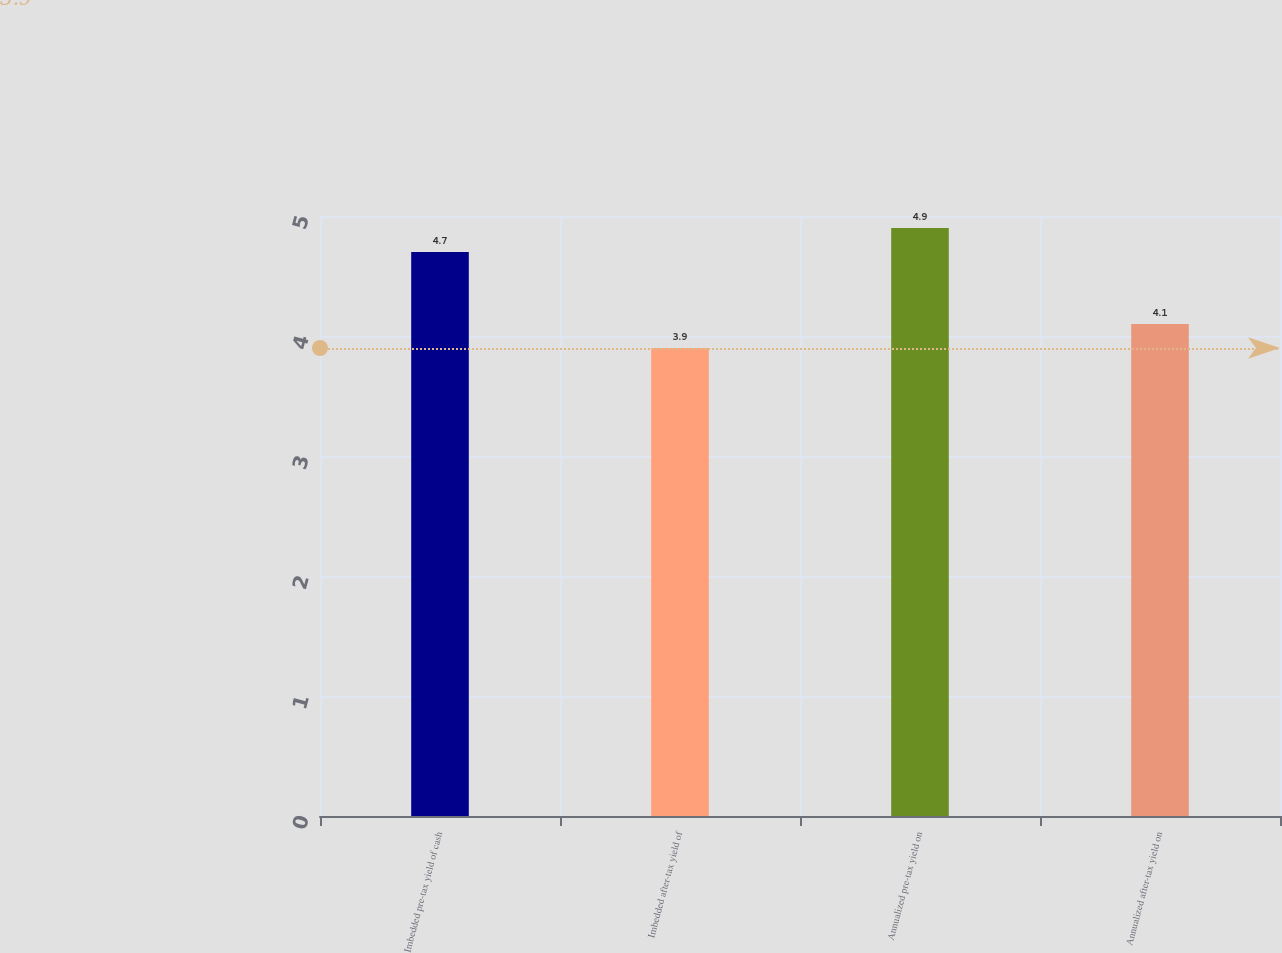Convert chart to OTSL. <chart><loc_0><loc_0><loc_500><loc_500><bar_chart><fcel>Imbedded pre-tax yield of cash<fcel>Imbedded after-tax yield of<fcel>Annualized pre-tax yield on<fcel>Annualized after-tax yield on<nl><fcel>4.7<fcel>3.9<fcel>4.9<fcel>4.1<nl></chart> 